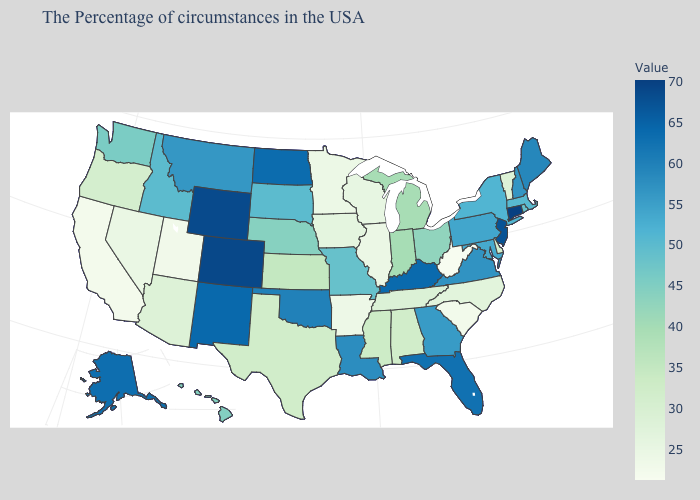Does Vermont have the lowest value in the Northeast?
Give a very brief answer. Yes. Among the states that border Pennsylvania , which have the lowest value?
Write a very short answer. West Virginia. Which states have the highest value in the USA?
Short answer required. Connecticut. Which states have the highest value in the USA?
Keep it brief. Connecticut. Does West Virginia have the lowest value in the USA?
Be succinct. Yes. Does Oregon have a lower value than Florida?
Be succinct. Yes. Among the states that border Rhode Island , does Connecticut have the highest value?
Keep it brief. Yes. Which states have the highest value in the USA?
Write a very short answer. Connecticut. Which states have the lowest value in the USA?
Short answer required. West Virginia. Among the states that border Washington , which have the lowest value?
Keep it brief. Oregon. 